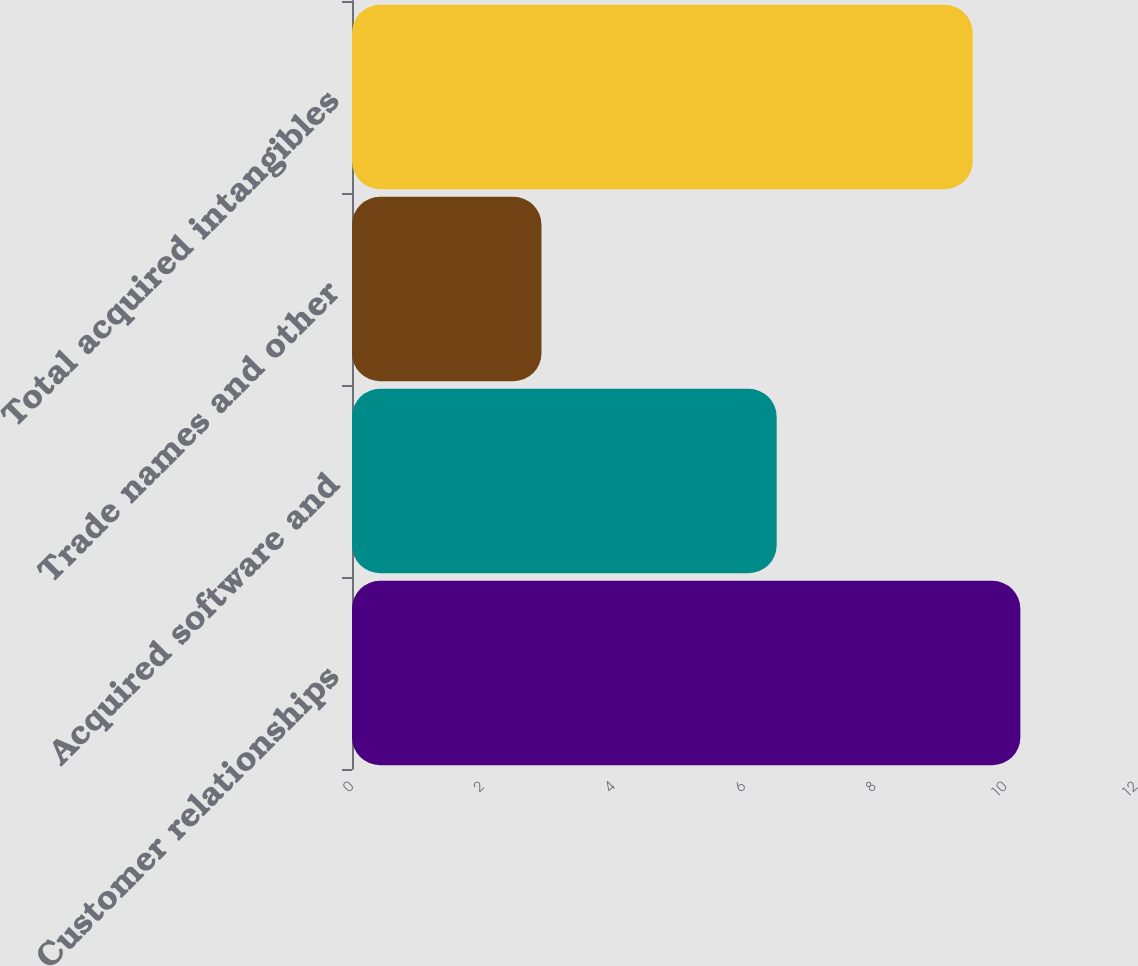Convert chart to OTSL. <chart><loc_0><loc_0><loc_500><loc_500><bar_chart><fcel>Customer relationships<fcel>Acquired software and<fcel>Trade names and other<fcel>Total acquired intangibles<nl><fcel>10.23<fcel>6.5<fcel>2.9<fcel>9.5<nl></chart> 